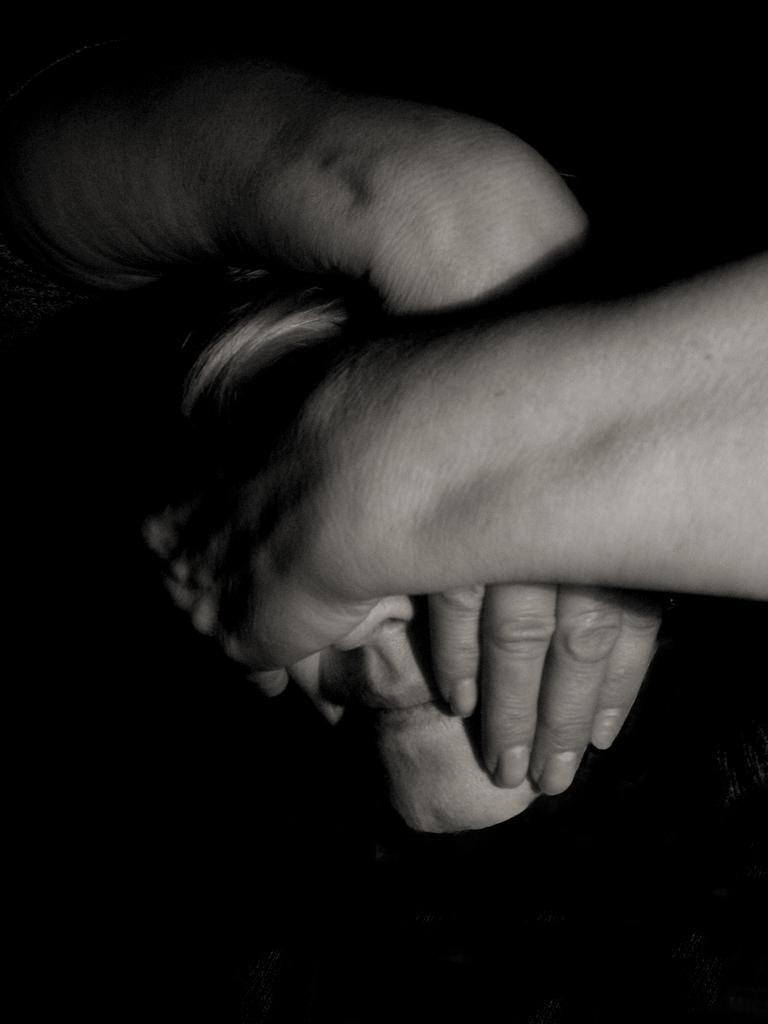Could you give a brief overview of what you see in this image? In the foreground of this image, there is a person's face covered with two hands of an another person. 